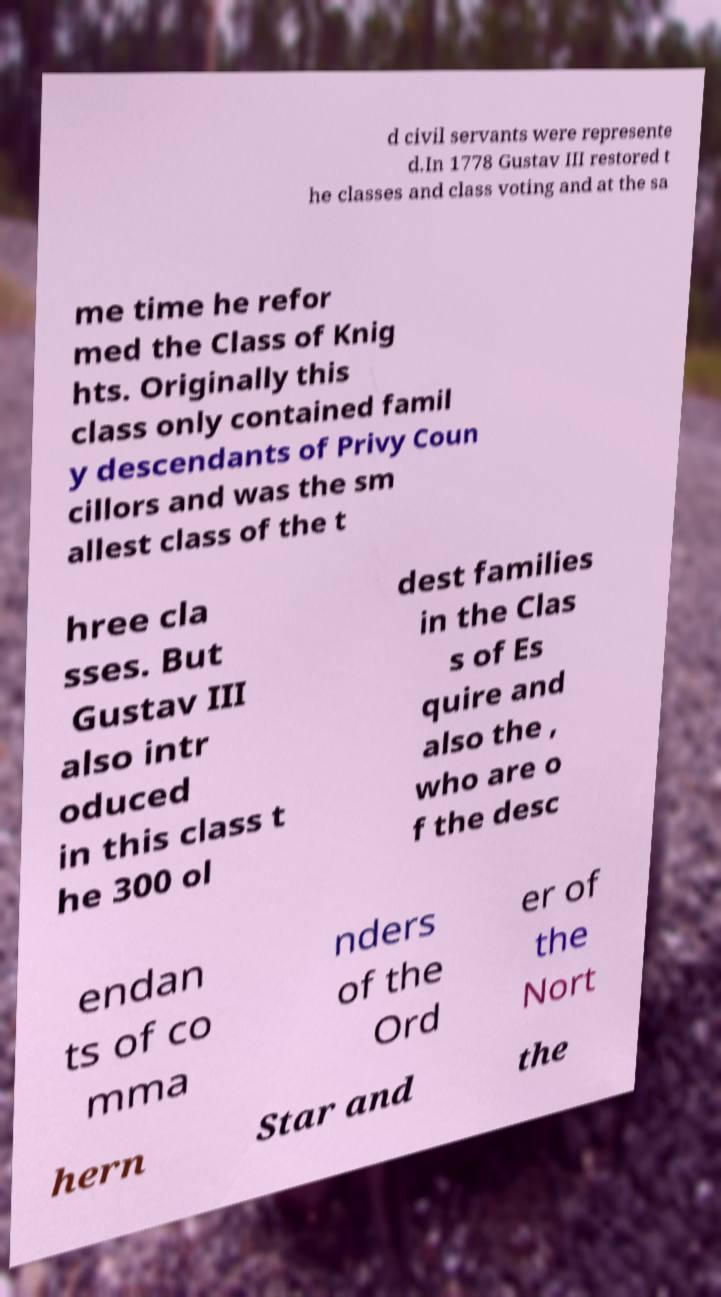Can you accurately transcribe the text from the provided image for me? d civil servants were represente d.In 1778 Gustav III restored t he classes and class voting and at the sa me time he refor med the Class of Knig hts. Originally this class only contained famil y descendants of Privy Coun cillors and was the sm allest class of the t hree cla sses. But Gustav III also intr oduced in this class t he 300 ol dest families in the Clas s of Es quire and also the , who are o f the desc endan ts of co mma nders of the Ord er of the Nort hern Star and the 